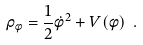Convert formula to latex. <formula><loc_0><loc_0><loc_500><loc_500>\rho _ { \phi } = \frac { 1 } { 2 } \dot { \phi } ^ { 2 } + V ( \phi ) \ .</formula> 